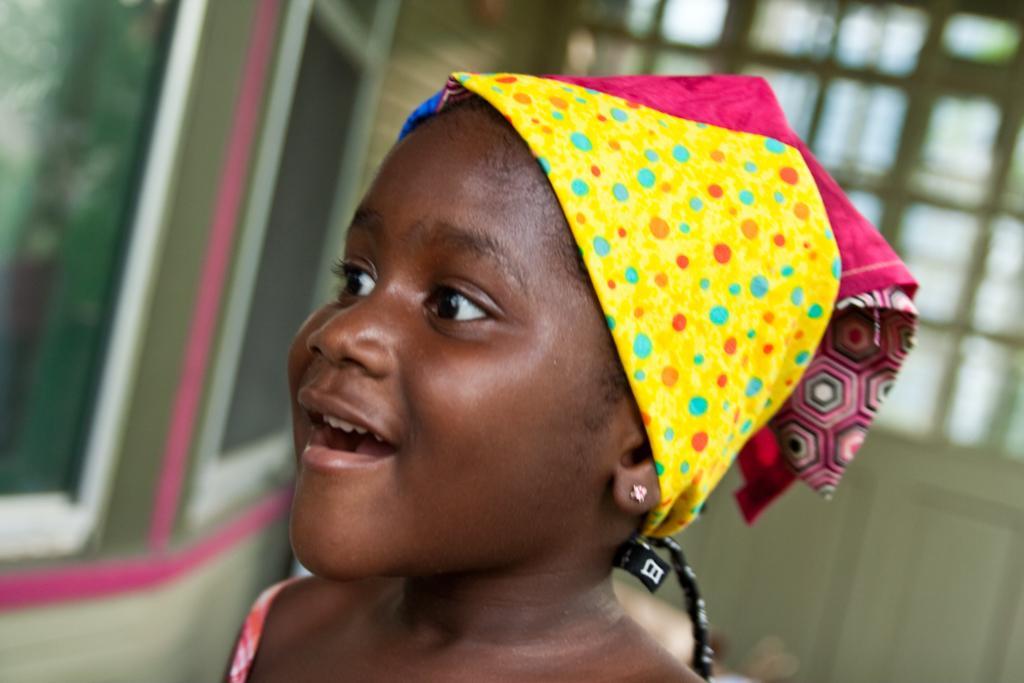In one or two sentences, can you explain what this image depicts? In the middle of this image, there is a girl wearing a cap, smiling and watching something. And the background is blurred. 